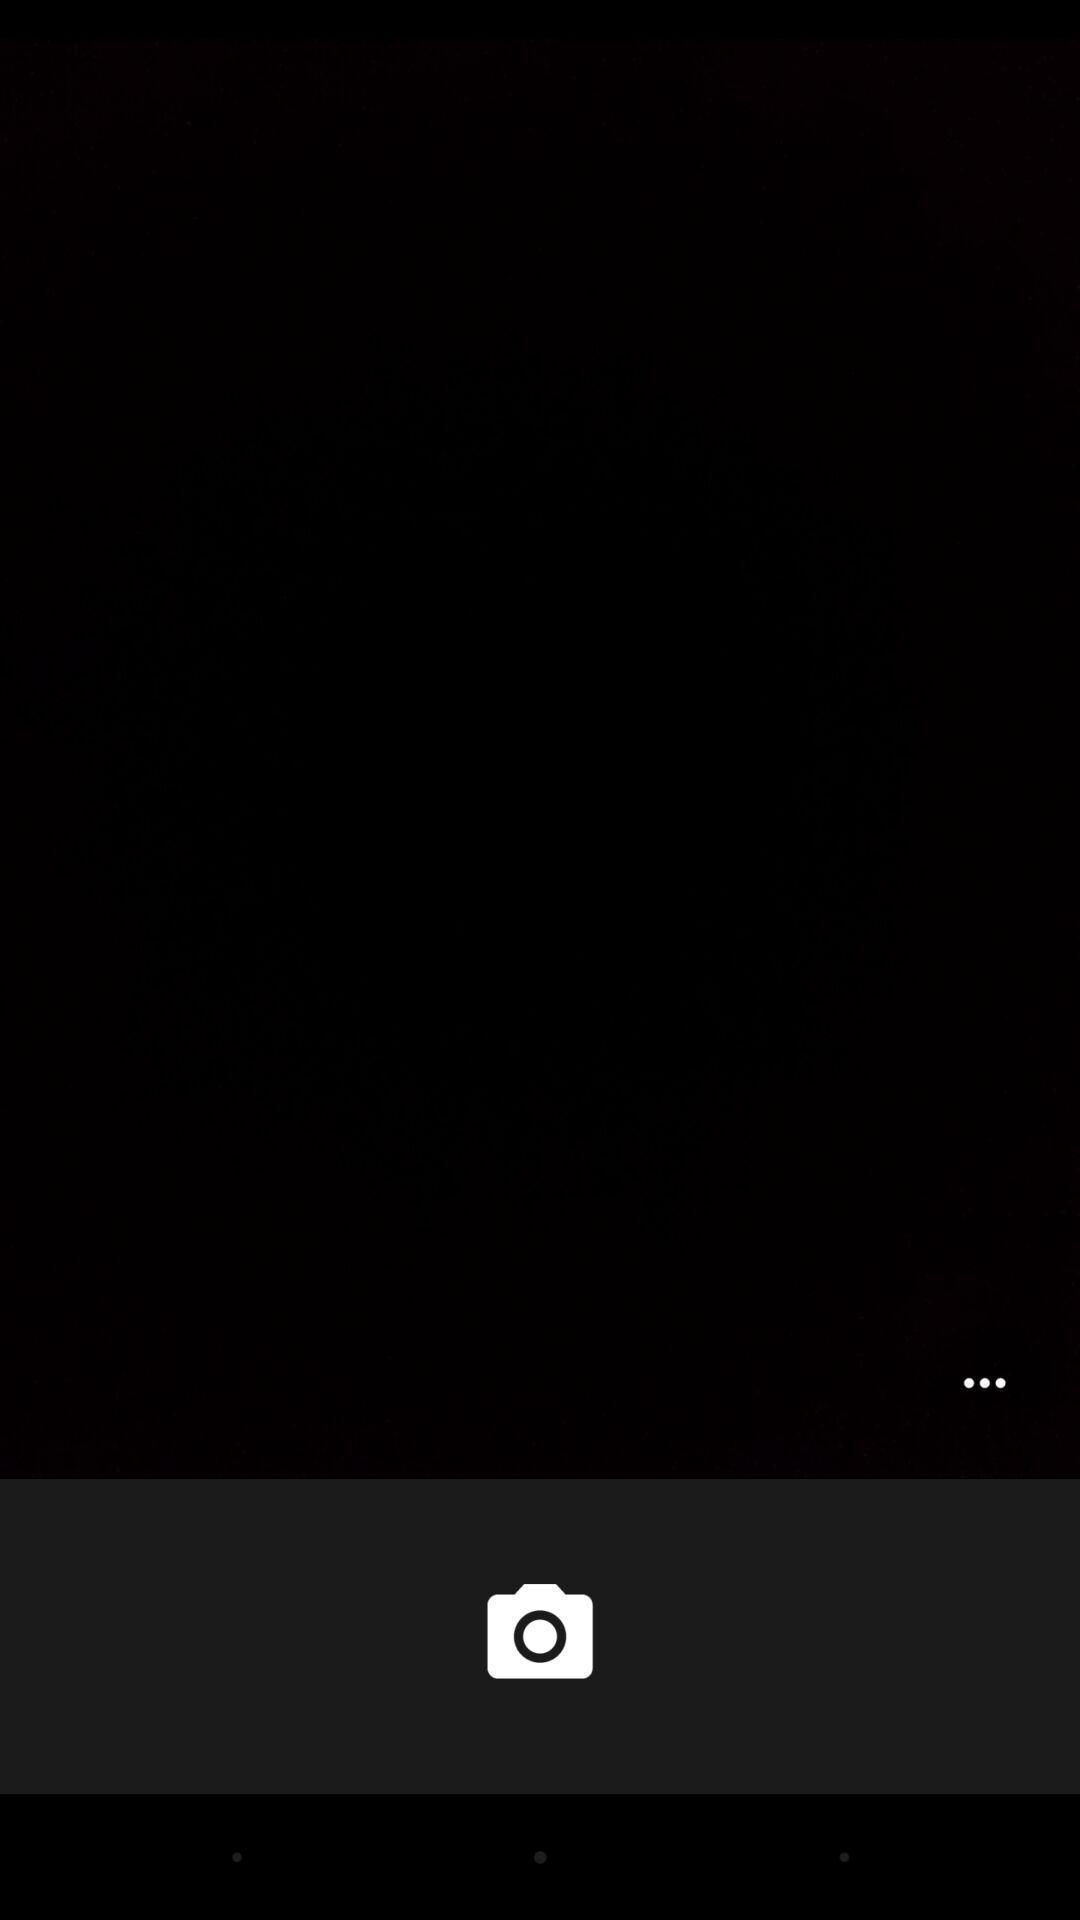Provide a textual representation of this image. Screen showing the blank page in camera app. 